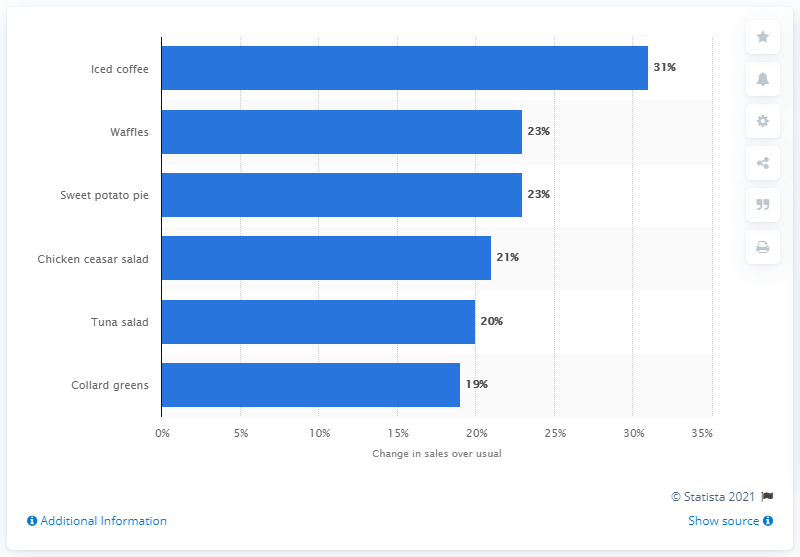Specify some key components in this picture. During the weekday game days of March Madness, iced coffee saw a significant increase in consumption. 